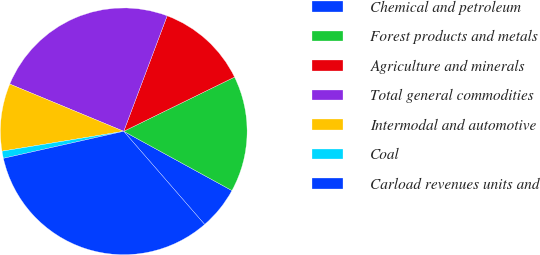Convert chart to OTSL. <chart><loc_0><loc_0><loc_500><loc_500><pie_chart><fcel>Chemical and petroleum<fcel>Forest products and metals<fcel>Agriculture and minerals<fcel>Total general commodities<fcel>Intermodal and automotive<fcel>Coal<fcel>Carload revenues units and<nl><fcel>5.64%<fcel>15.22%<fcel>12.03%<fcel>24.47%<fcel>8.83%<fcel>0.94%<fcel>32.87%<nl></chart> 